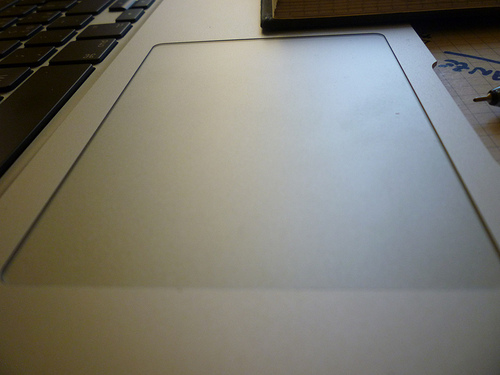<image>
Can you confirm if the mouse pad is on the key board? No. The mouse pad is not positioned on the key board. They may be near each other, but the mouse pad is not supported by or resting on top of the key board. 